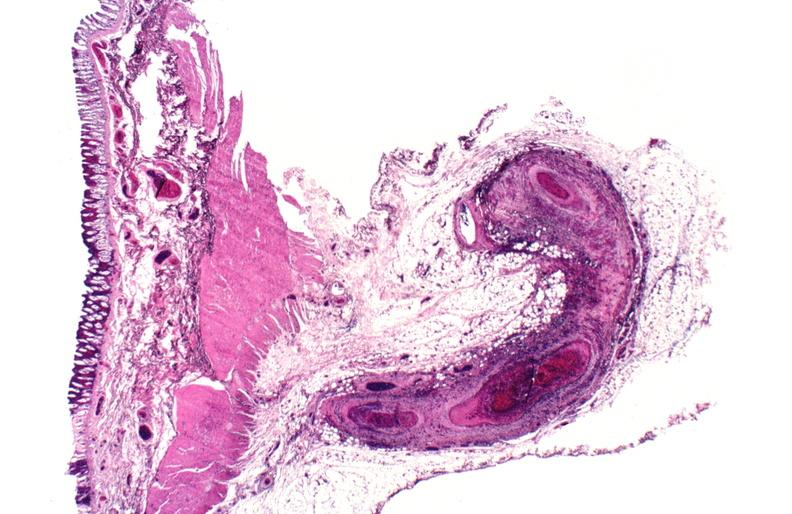does aldehyde fuscin show polyarteritis nodosa?
Answer the question using a single word or phrase. No 